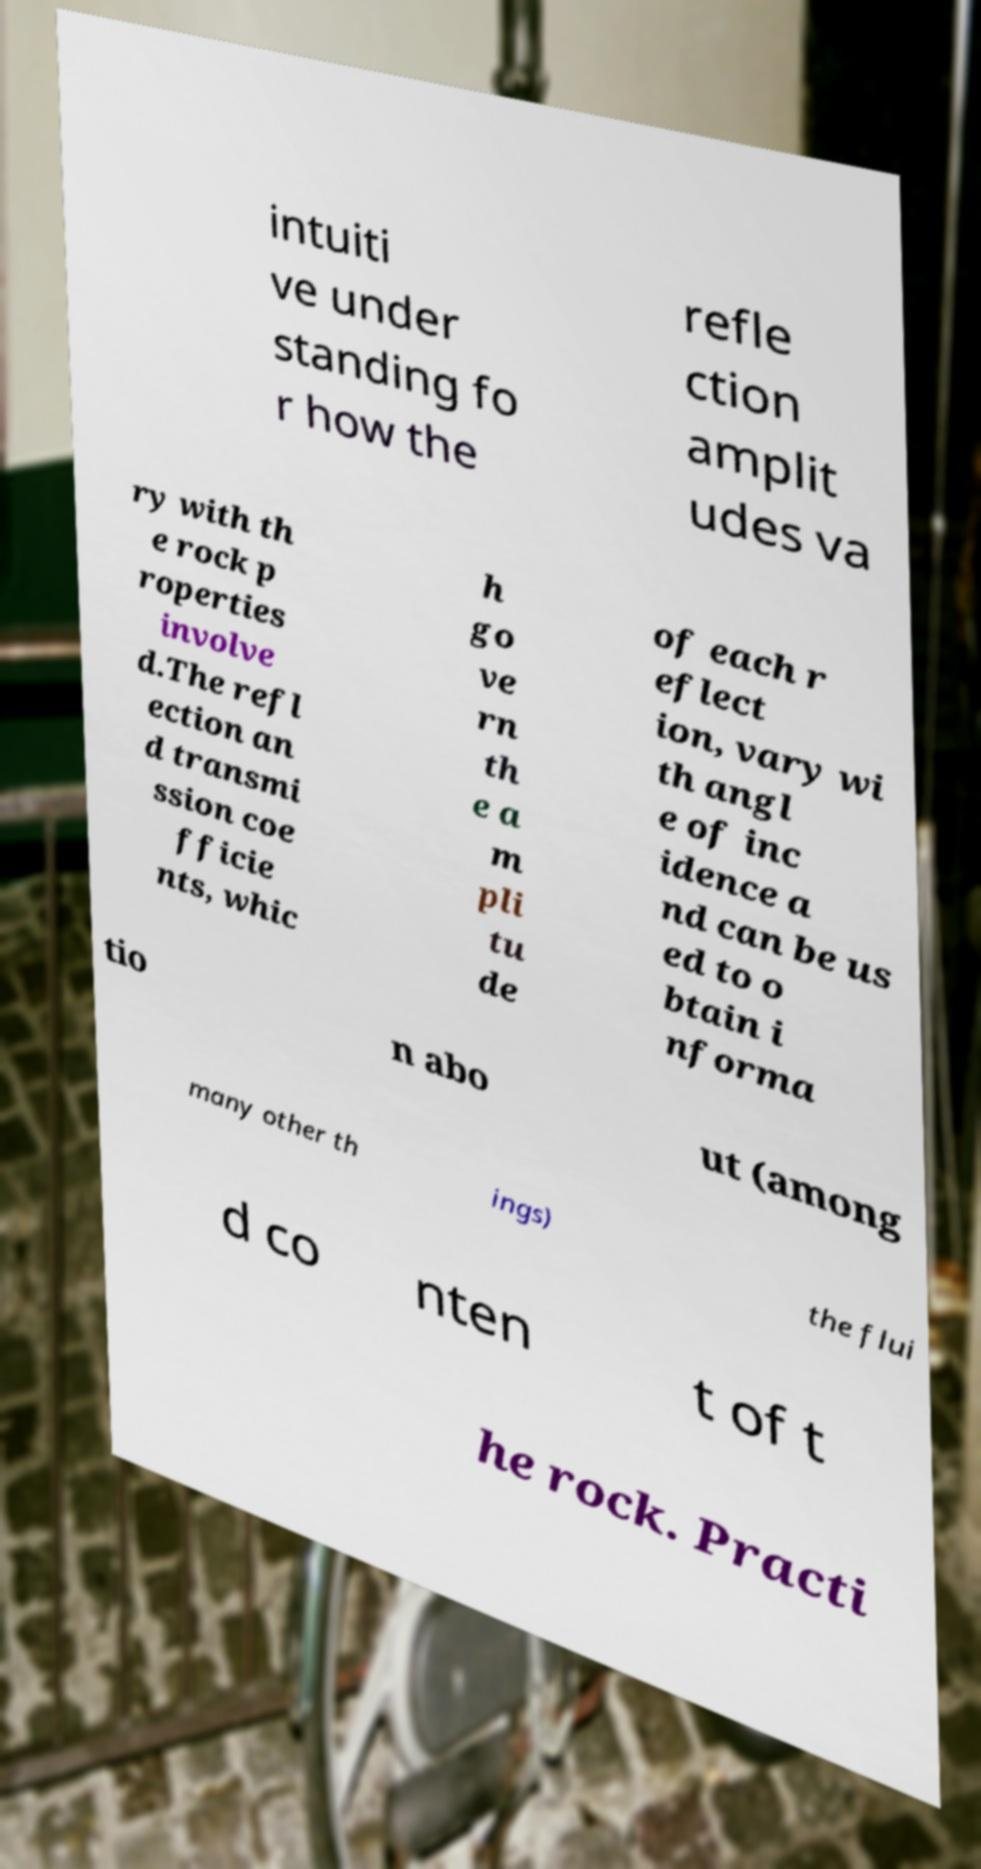Could you assist in decoding the text presented in this image and type it out clearly? intuiti ve under standing fo r how the refle ction amplit udes va ry with th e rock p roperties involve d.The refl ection an d transmi ssion coe fficie nts, whic h go ve rn th e a m pli tu de of each r eflect ion, vary wi th angl e of inc idence a nd can be us ed to o btain i nforma tio n abo ut (among many other th ings) the flui d co nten t of t he rock. Practi 